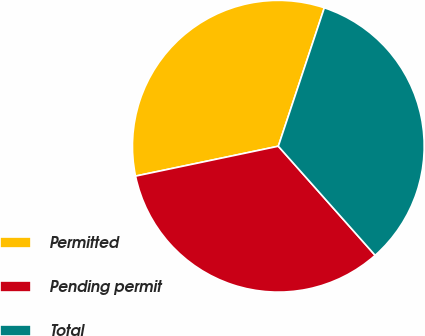<chart> <loc_0><loc_0><loc_500><loc_500><pie_chart><fcel>Permitted<fcel>Pending permit<fcel>Total<nl><fcel>33.39%<fcel>33.27%<fcel>33.34%<nl></chart> 